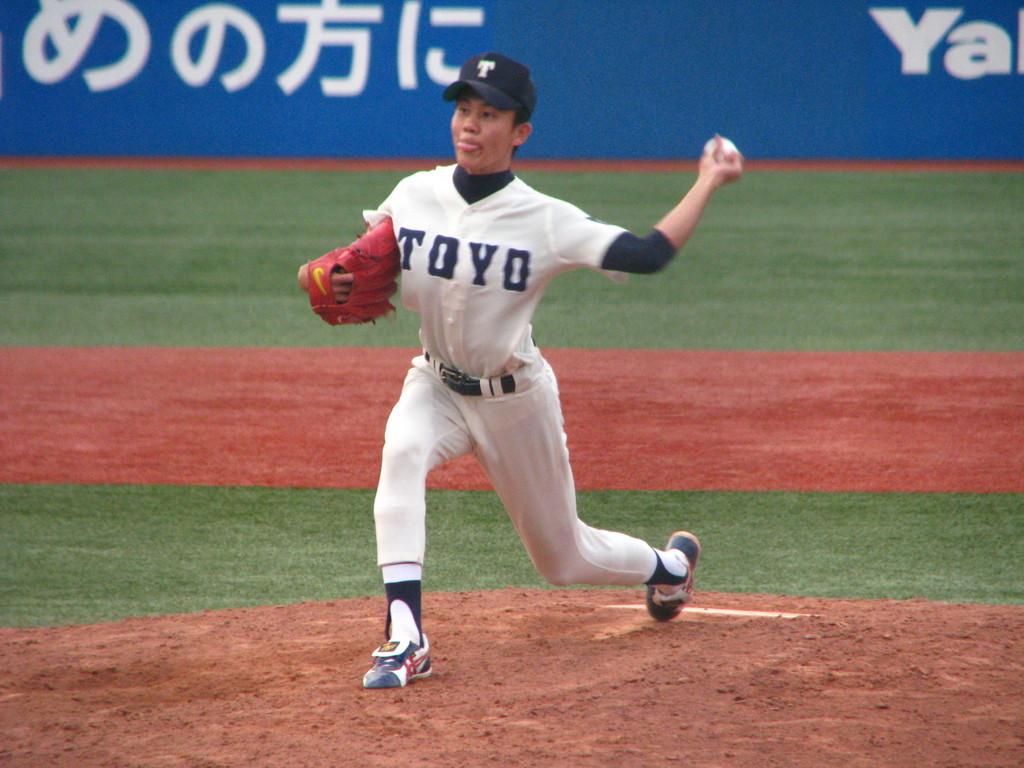What letter is on the player's hat?
Your answer should be very brief. T. Which team does the pitcher belong to?
Make the answer very short. Toyo. 